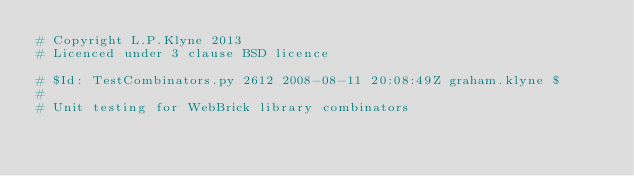Convert code to text. <code><loc_0><loc_0><loc_500><loc_500><_Python_># Copyright L.P.Klyne 2013 
# Licenced under 3 clause BSD licence 

# $Id: TestCombinators.py 2612 2008-08-11 20:08:49Z graham.klyne $
#
# Unit testing for WebBrick library combinators</code> 